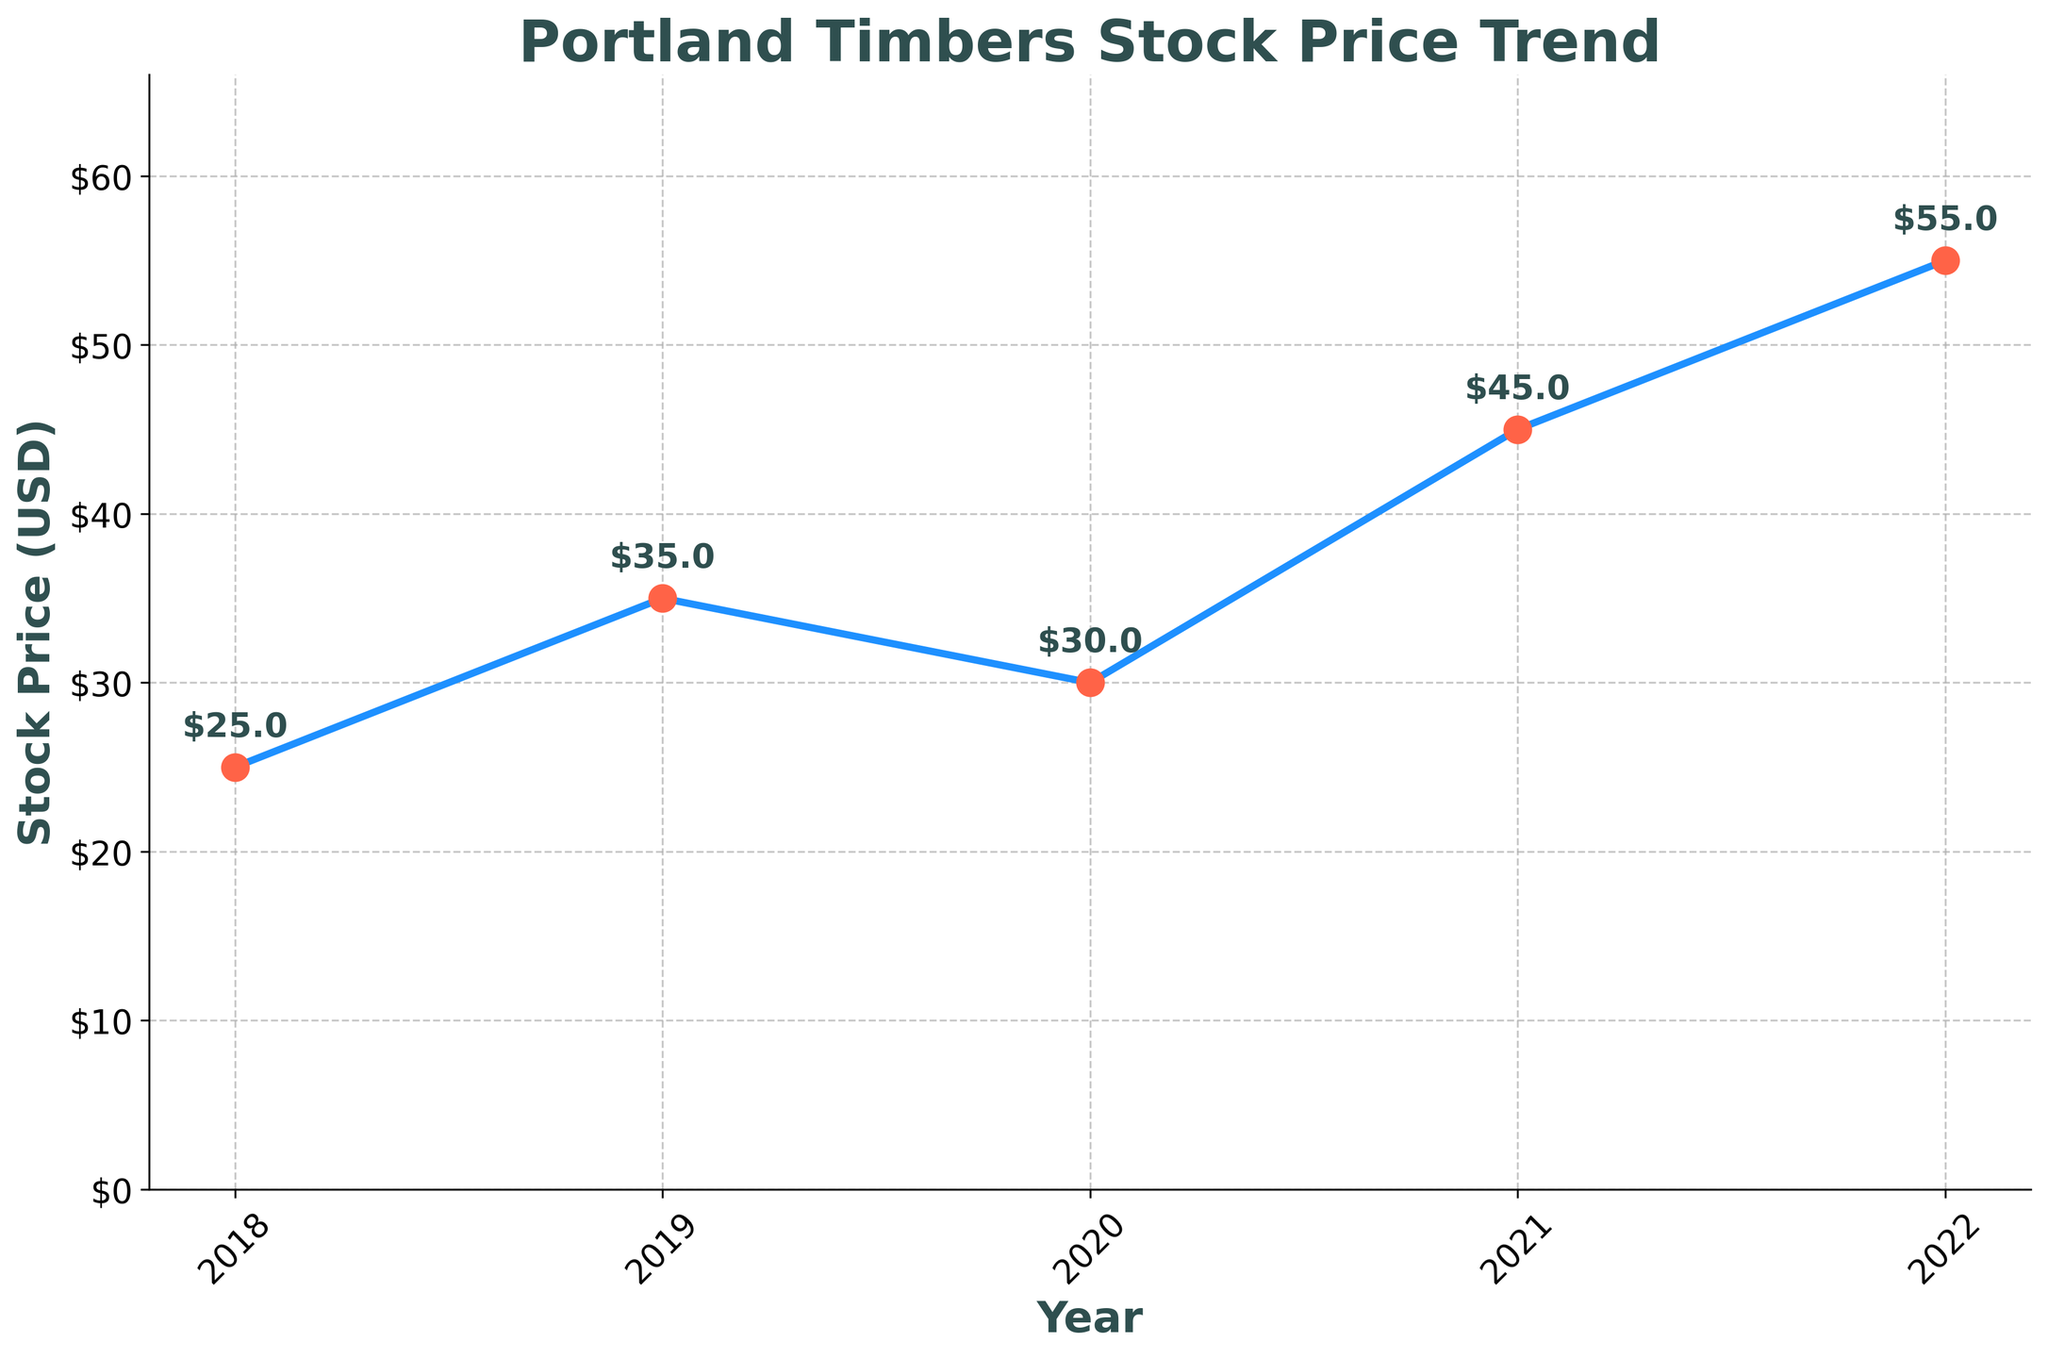What is the title of the plot? The title of the plot is displayed prominently at the top. It reads "Portland Timbers Stock Price Trend."
Answer: Portland Timbers Stock Price Trend What does the y-axis represent in the plot? The y-axis represents the stock price in USD, as indicated by the label "Stock Price (USD)."
Answer: Stock Price (USD) Between which years does the plot show data? The plot has data points from the years 2018 to 2022, which are marked on the x-axis.
Answer: 2018 to 2022 How many data points are represented in the plot? There are five data points in the plot, each corresponding to a year from 2018 to 2022.
Answer: 5 What is the highest stock price shown in the plot, and in which year was it recorded? The highest stock price shown in the plot is $55, recorded in the year 2022.
Answer: $55 in 2022 What is the lowest stock price shown in the plot, and in which year was it recorded? The lowest stock price shown in the plot is $25, recorded in the year 2018.
Answer: $25 in 2018 By how much did the stock price increase from 2018 to 2022? The stock price in 2018 was $25, and it increased to $55 by 2022. The difference is $55 - $25 = $30.
Answer: $30 Which year saw the largest increase in stock price from the previous year? To identify the largest increase, we compare the differences year by year: 
2019 vs. 2018: $35 - $25 = $10 
2020 vs. 2019: $30 - $35 = -$5 
2021 vs. 2020: $45 - $30 = $15 
2022 vs. 2021: $55 - $45 = $10 
The largest increase of $15 occurred from 2020 to 2021.
Answer: 2021 On average, what was the stock price over the five years? The average stock price is calculated by summing all the prices and dividing by the number of years.
($25 + $35 + $30 + $45 + $55) / 5 = $190 / 5 = $38
Answer: $38 How did the stock price trend change from 2019 to 2020? From 2019 to 2020, the stock price decreased from $35 to $30.
Answer: It decreased 